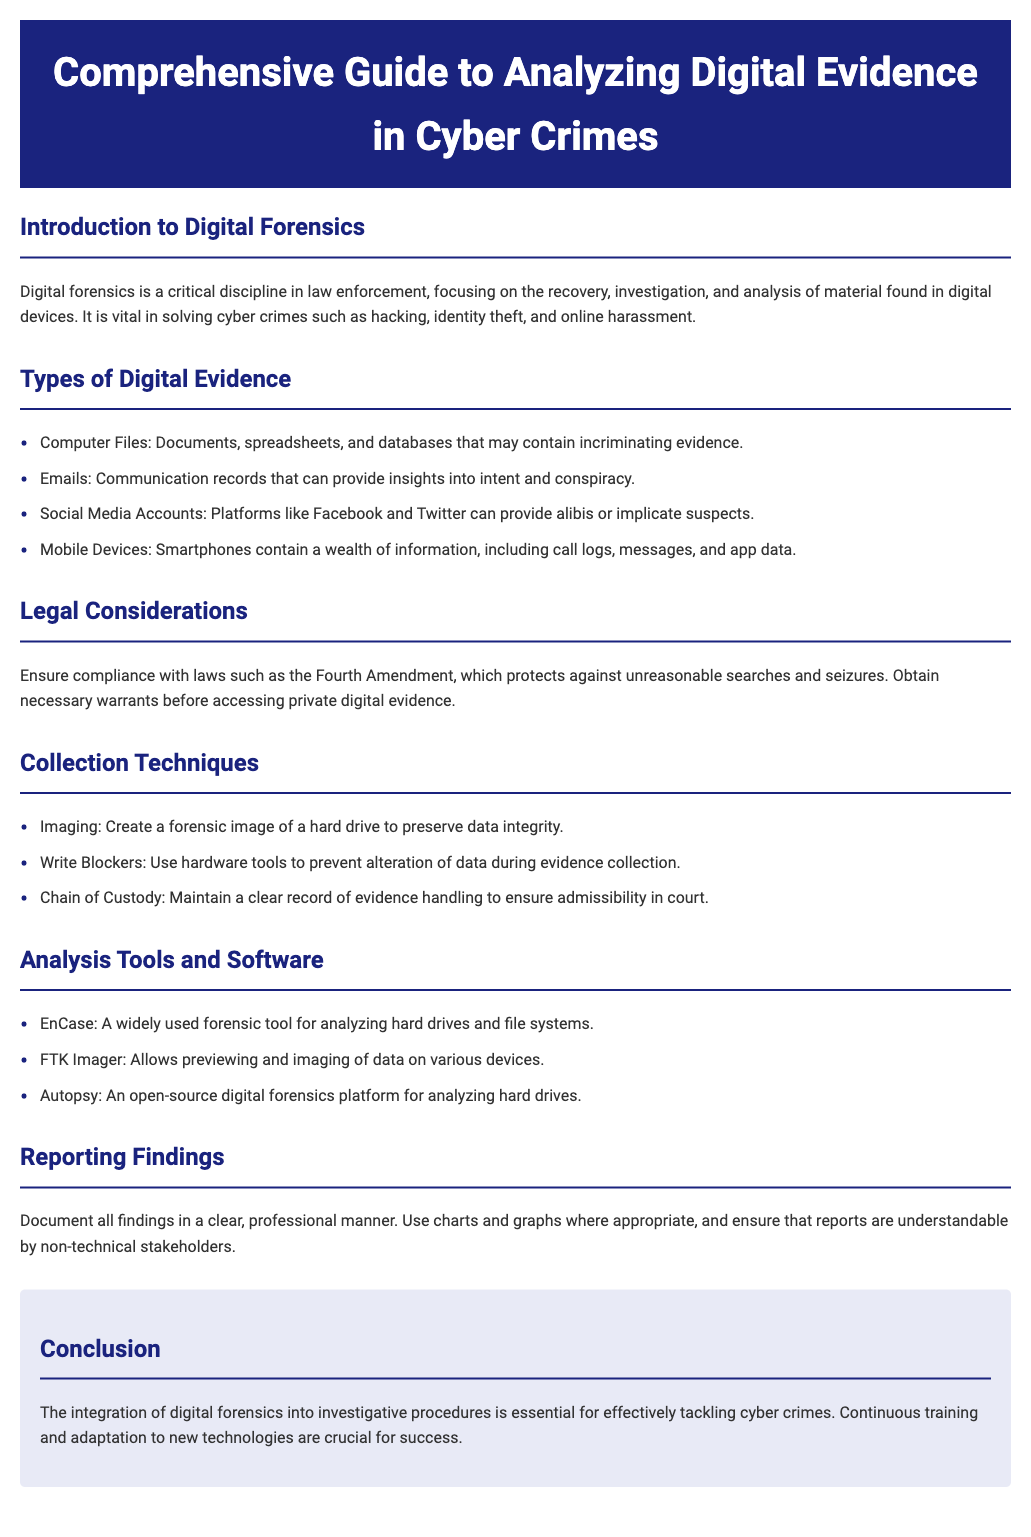What is the main focus of digital forensics? The main focus of digital forensics is the recovery, investigation, and analysis of material found in digital devices, used to solve cyber crimes.
Answer: Cyber crimes What are the types of digital evidence mentioned? The document lists types of digital evidence including computer files, emails, social media accounts, and mobile devices.
Answer: Computer Files, Emails, Social Media Accounts, Mobile Devices Which amendment should law enforcement comply with? The document specifies the Fourth Amendment, which protects against unreasonable searches and seizures.
Answer: Fourth Amendment What is one technique used for evidence collection? The document mentions imaging as a technique to create a forensic image of a hard drive to preserve data integrity.
Answer: Imaging Name one analysis tool mentioned in the document. The document lists software tools for analysis, including EnCase, FTK Imager, and Autopsy.
Answer: EnCase What is crucial for maintaining the admissibility of evidence in court? The document states that maintaining a clear record of evidence handling through the chain of custody is crucial for admissibility.
Answer: Chain of Custody What should findings be documented in? The conclusions should ensure that reports are in a clear, professional manner and understandable by non-technical stakeholders, indicating the format for documentation.
Answer: Clear, professional manner What is essential for effectively tackling cyber crimes? The document emphasizes that the integration of digital forensics into investigative procedures is essential for this purpose.
Answer: Integration of digital forensics 